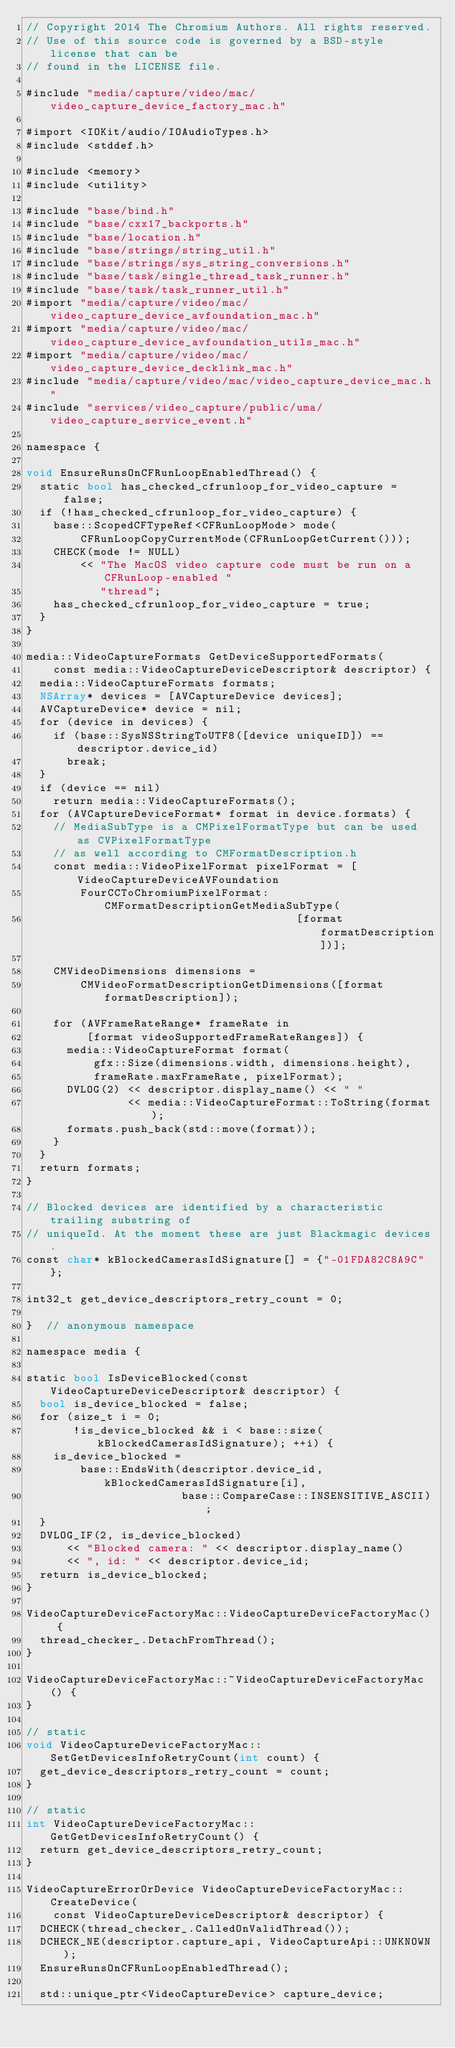Convert code to text. <code><loc_0><loc_0><loc_500><loc_500><_ObjectiveC_>// Copyright 2014 The Chromium Authors. All rights reserved.
// Use of this source code is governed by a BSD-style license that can be
// found in the LICENSE file.

#include "media/capture/video/mac/video_capture_device_factory_mac.h"

#import <IOKit/audio/IOAudioTypes.h>
#include <stddef.h>

#include <memory>
#include <utility>

#include "base/bind.h"
#include "base/cxx17_backports.h"
#include "base/location.h"
#include "base/strings/string_util.h"
#include "base/strings/sys_string_conversions.h"
#include "base/task/single_thread_task_runner.h"
#include "base/task/task_runner_util.h"
#import "media/capture/video/mac/video_capture_device_avfoundation_mac.h"
#import "media/capture/video/mac/video_capture_device_avfoundation_utils_mac.h"
#import "media/capture/video/mac/video_capture_device_decklink_mac.h"
#include "media/capture/video/mac/video_capture_device_mac.h"
#include "services/video_capture/public/uma/video_capture_service_event.h"

namespace {

void EnsureRunsOnCFRunLoopEnabledThread() {
  static bool has_checked_cfrunloop_for_video_capture = false;
  if (!has_checked_cfrunloop_for_video_capture) {
    base::ScopedCFTypeRef<CFRunLoopMode> mode(
        CFRunLoopCopyCurrentMode(CFRunLoopGetCurrent()));
    CHECK(mode != NULL)
        << "The MacOS video capture code must be run on a CFRunLoop-enabled "
           "thread";
    has_checked_cfrunloop_for_video_capture = true;
  }
}

media::VideoCaptureFormats GetDeviceSupportedFormats(
    const media::VideoCaptureDeviceDescriptor& descriptor) {
  media::VideoCaptureFormats formats;
  NSArray* devices = [AVCaptureDevice devices];
  AVCaptureDevice* device = nil;
  for (device in devices) {
    if (base::SysNSStringToUTF8([device uniqueID]) == descriptor.device_id)
      break;
  }
  if (device == nil)
    return media::VideoCaptureFormats();
  for (AVCaptureDeviceFormat* format in device.formats) {
    // MediaSubType is a CMPixelFormatType but can be used as CVPixelFormatType
    // as well according to CMFormatDescription.h
    const media::VideoPixelFormat pixelFormat = [VideoCaptureDeviceAVFoundation
        FourCCToChromiumPixelFormat:CMFormatDescriptionGetMediaSubType(
                                        [format formatDescription])];

    CMVideoDimensions dimensions =
        CMVideoFormatDescriptionGetDimensions([format formatDescription]);

    for (AVFrameRateRange* frameRate in
         [format videoSupportedFrameRateRanges]) {
      media::VideoCaptureFormat format(
          gfx::Size(dimensions.width, dimensions.height),
          frameRate.maxFrameRate, pixelFormat);
      DVLOG(2) << descriptor.display_name() << " "
               << media::VideoCaptureFormat::ToString(format);
      formats.push_back(std::move(format));
    }
  }
  return formats;
}

// Blocked devices are identified by a characteristic trailing substring of
// uniqueId. At the moment these are just Blackmagic devices.
const char* kBlockedCamerasIdSignature[] = {"-01FDA82C8A9C"};

int32_t get_device_descriptors_retry_count = 0;

}  // anonymous namespace

namespace media {

static bool IsDeviceBlocked(const VideoCaptureDeviceDescriptor& descriptor) {
  bool is_device_blocked = false;
  for (size_t i = 0;
       !is_device_blocked && i < base::size(kBlockedCamerasIdSignature); ++i) {
    is_device_blocked =
        base::EndsWith(descriptor.device_id, kBlockedCamerasIdSignature[i],
                       base::CompareCase::INSENSITIVE_ASCII);
  }
  DVLOG_IF(2, is_device_blocked)
      << "Blocked camera: " << descriptor.display_name()
      << ", id: " << descriptor.device_id;
  return is_device_blocked;
}

VideoCaptureDeviceFactoryMac::VideoCaptureDeviceFactoryMac() {
  thread_checker_.DetachFromThread();
}

VideoCaptureDeviceFactoryMac::~VideoCaptureDeviceFactoryMac() {
}

// static
void VideoCaptureDeviceFactoryMac::SetGetDevicesInfoRetryCount(int count) {
  get_device_descriptors_retry_count = count;
}

// static
int VideoCaptureDeviceFactoryMac::GetGetDevicesInfoRetryCount() {
  return get_device_descriptors_retry_count;
}

VideoCaptureErrorOrDevice VideoCaptureDeviceFactoryMac::CreateDevice(
    const VideoCaptureDeviceDescriptor& descriptor) {
  DCHECK(thread_checker_.CalledOnValidThread());
  DCHECK_NE(descriptor.capture_api, VideoCaptureApi::UNKNOWN);
  EnsureRunsOnCFRunLoopEnabledThread();

  std::unique_ptr<VideoCaptureDevice> capture_device;</code> 